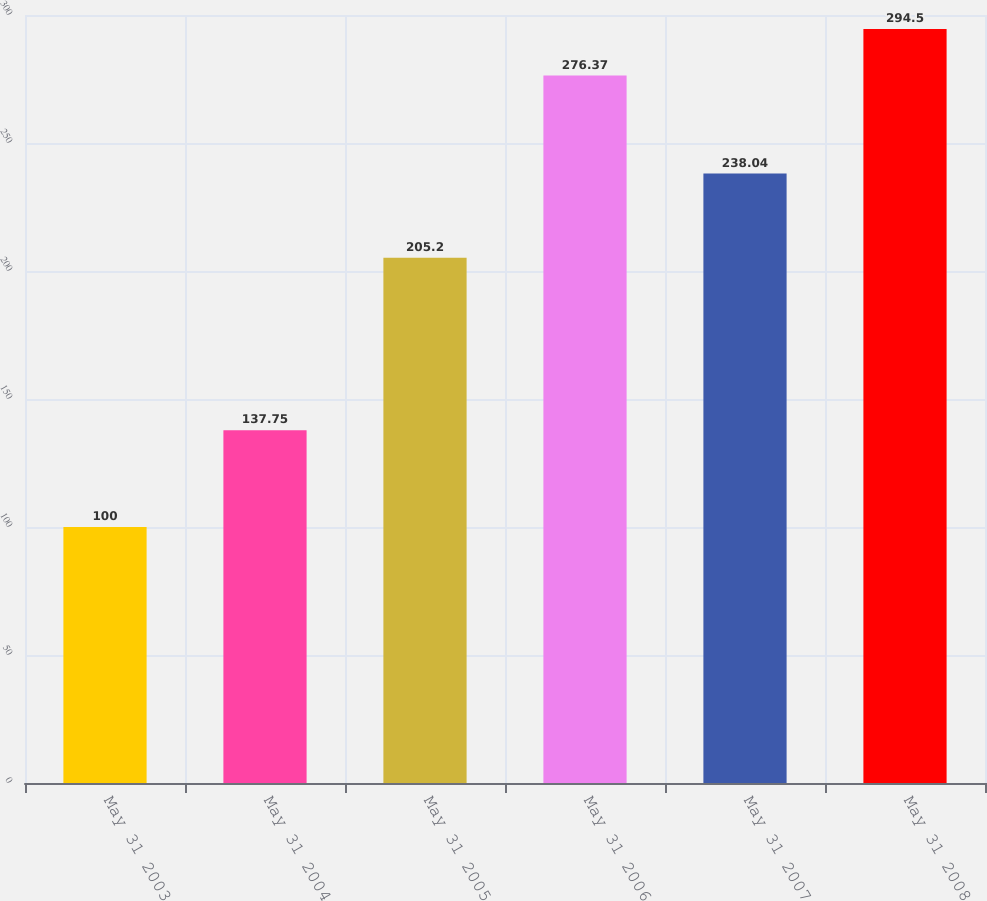Convert chart to OTSL. <chart><loc_0><loc_0><loc_500><loc_500><bar_chart><fcel>May 31 2003<fcel>May 31 2004<fcel>May 31 2005<fcel>May 31 2006<fcel>May 31 2007<fcel>May 31 2008<nl><fcel>100<fcel>137.75<fcel>205.2<fcel>276.37<fcel>238.04<fcel>294.5<nl></chart> 